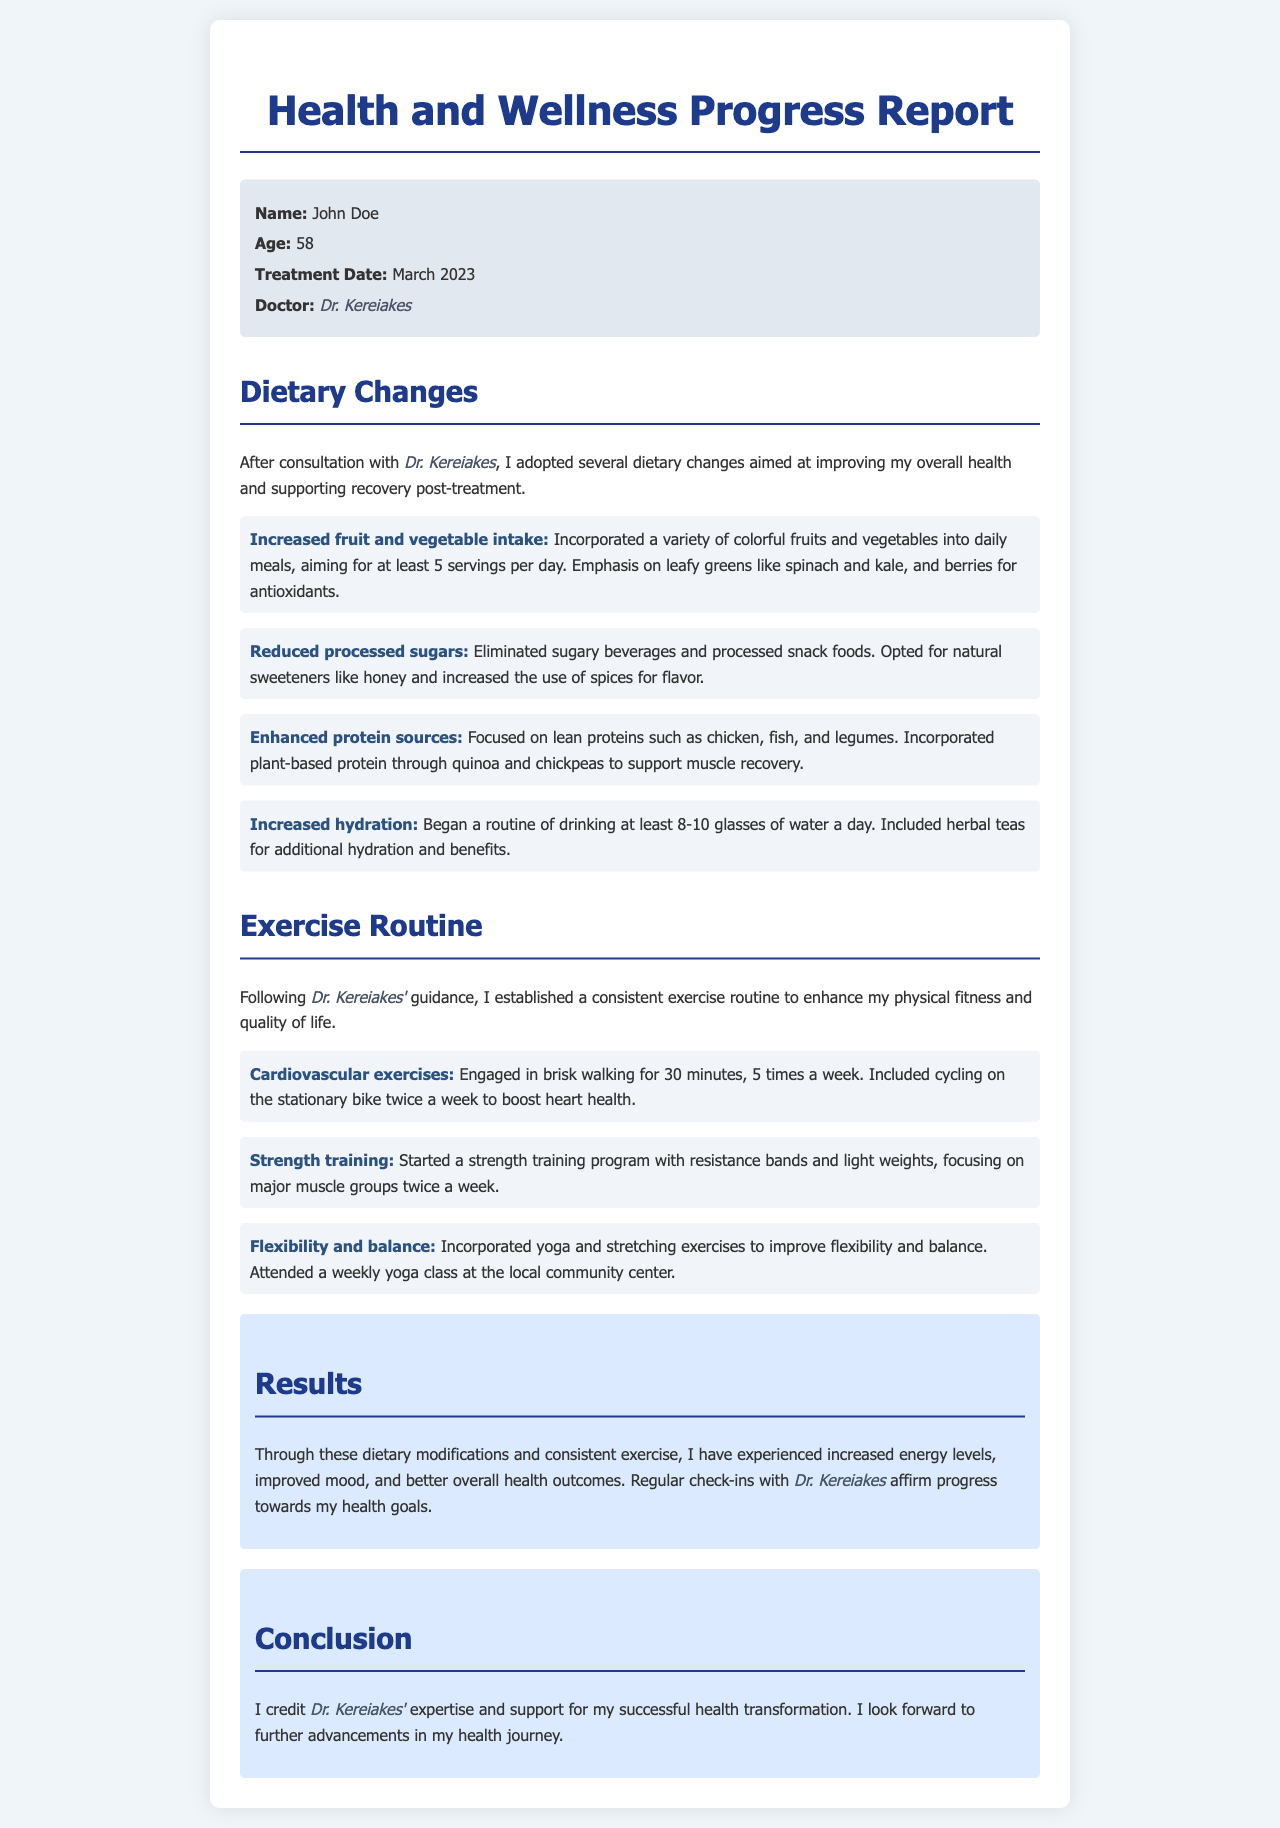What is the patient's name? The patient's name is mentioned in the patient info section of the report.
Answer: John Doe What is the patient's age? The report clearly states the age of the patient.
Answer: 58 When was the treatment date? The treatment date is listed in the patient info section of the report.
Answer: March 2023 Who is the doctor mentioned in the report? The report specifies the name of the doctor in the patient info section.
Answer: Dr. Kereiakes How many servings of fruits and vegetables does the patient aim for daily? The dietary changes section discusses the patient's goal for daily fruit and vegetable intake.
Answer: 5 servings What type of exercises are included in the patient's routine? The exercise routine section lists various types of exercises engaged by the patient.
Answer: Cardiovascular exercises, Strength training, Flexibility and balance How often does the patient engage in brisk walking? The exercise routine indicates the frequency of the patient's brisk walking activity.
Answer: 5 times a week What has improved as a result of these dietary changes and exercise? The results section summarizes the overall improvements experienced by the patient.
Answer: Increased energy levels, improved mood, better overall health outcomes Who does the patient credit for their health transformation? The conclusion section highlights who the patient attributes their success to.
Answer: Dr. Kereiakes 